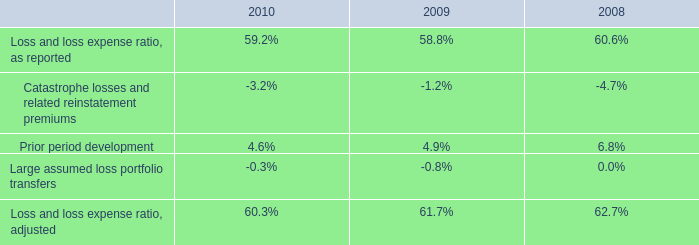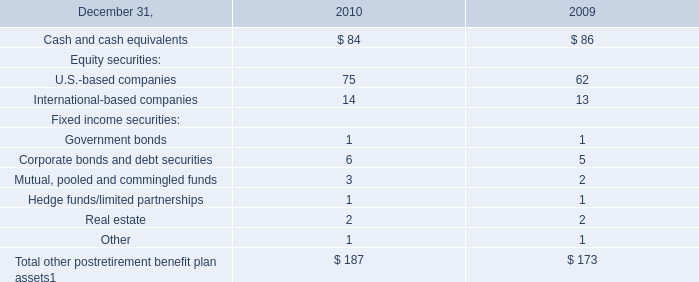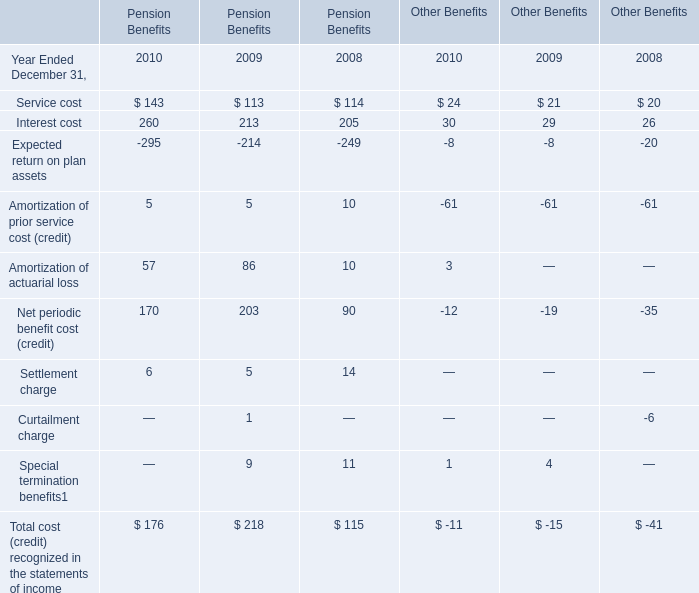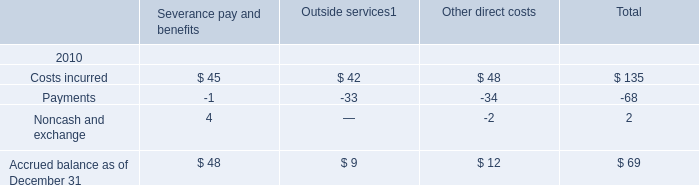In the year with the greatest proportion of Mutual, pooled and commingled funds, what is the proportion of Mutual, pooled and commingled funds to the tatal? 
Computations: (3 / 187)
Answer: 0.01604. 